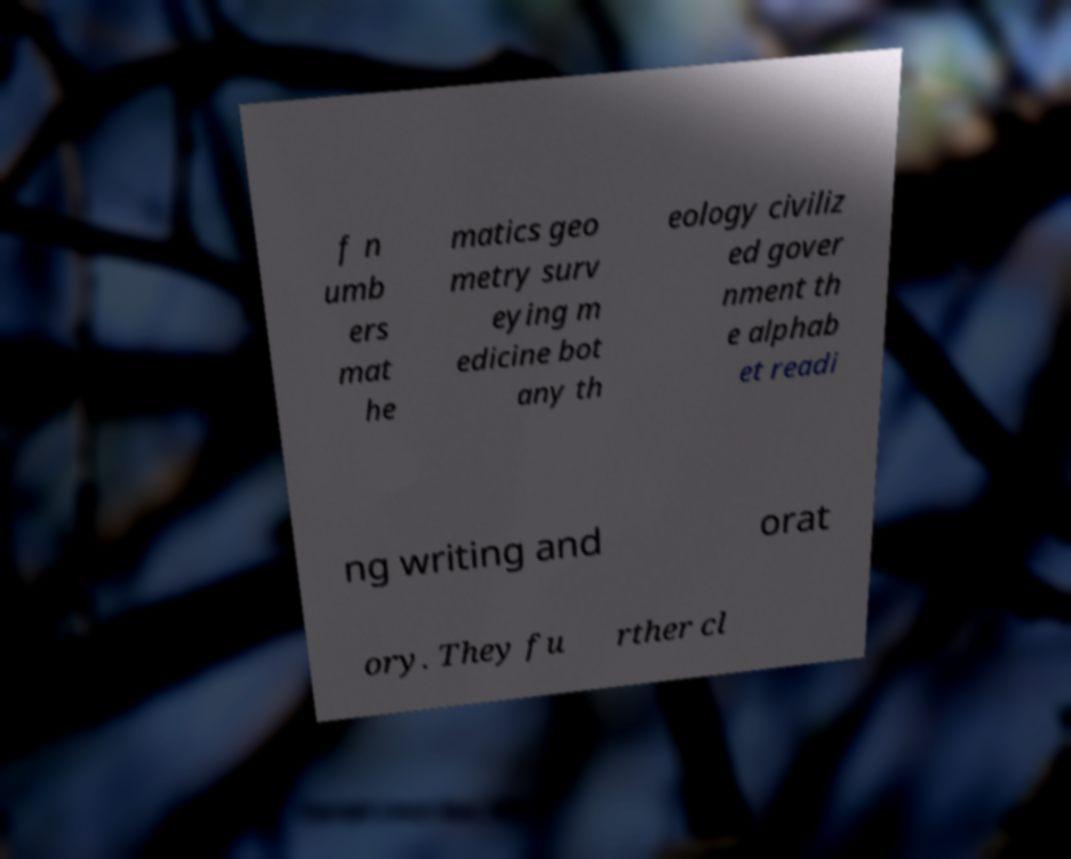For documentation purposes, I need the text within this image transcribed. Could you provide that? f n umb ers mat he matics geo metry surv eying m edicine bot any th eology civiliz ed gover nment th e alphab et readi ng writing and orat ory. They fu rther cl 